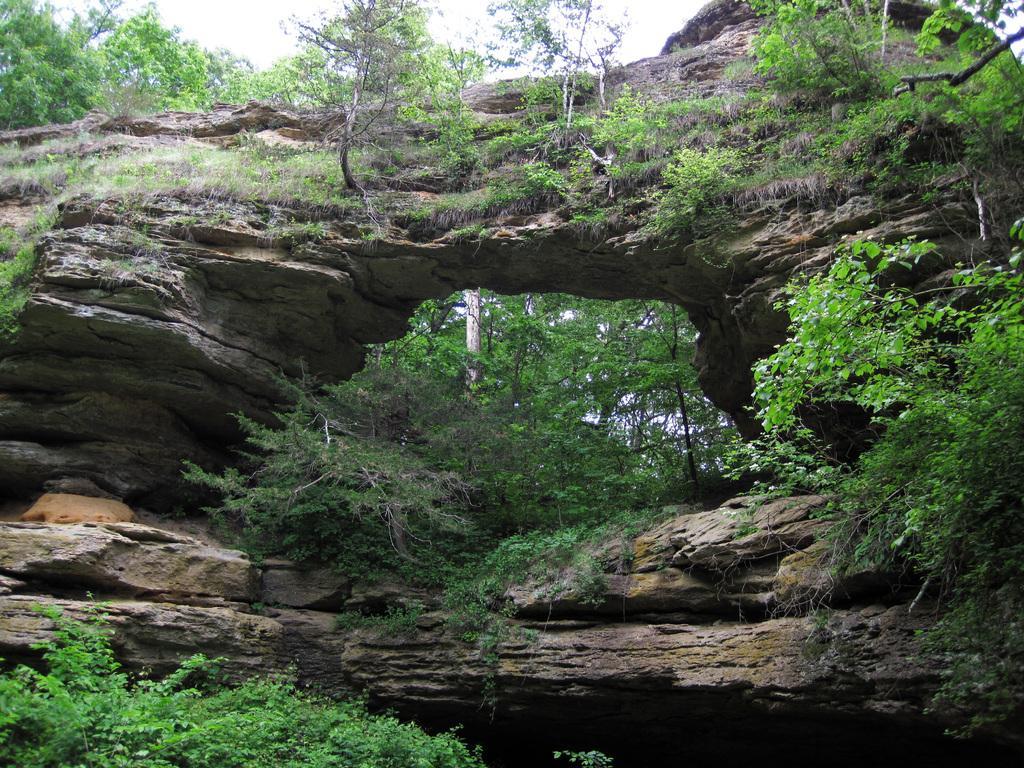Could you give a brief overview of what you see in this image? In this image we can see a stone arch, plants, trees and other objects. In the background of the image there are trees, plants and the sky. At the bottom of the image there are stones and the plants. 